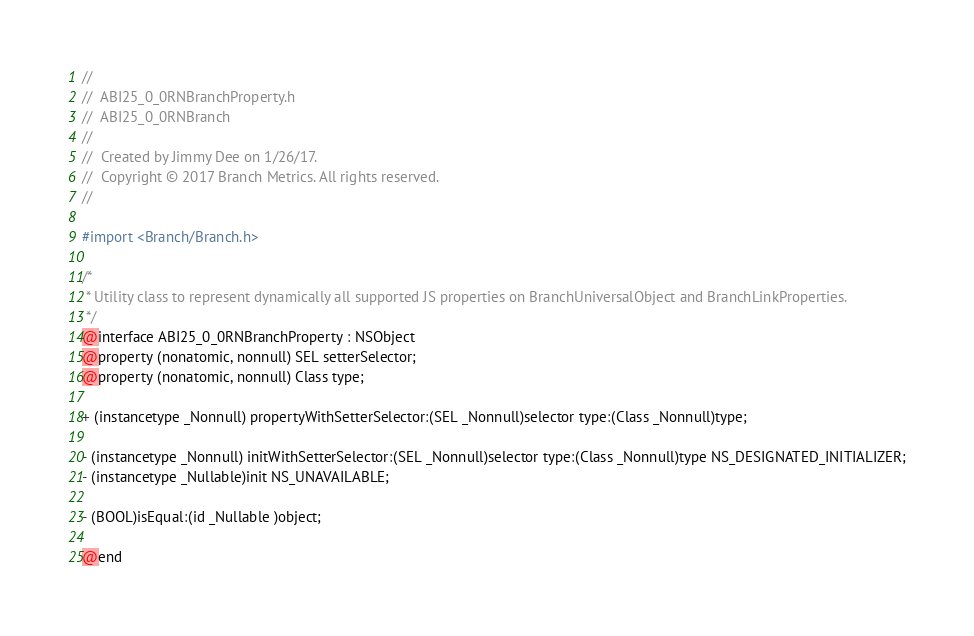<code> <loc_0><loc_0><loc_500><loc_500><_C_>//
//  ABI25_0_0RNBranchProperty.h
//  ABI25_0_0RNBranch
//
//  Created by Jimmy Dee on 1/26/17.
//  Copyright © 2017 Branch Metrics. All rights reserved.
//

#import <Branch/Branch.h>

/*
 * Utility class to represent dynamically all supported JS properties on BranchUniversalObject and BranchLinkProperties.
 */
@interface ABI25_0_0RNBranchProperty : NSObject
@property (nonatomic, nonnull) SEL setterSelector;
@property (nonatomic, nonnull) Class type;

+ (instancetype _Nonnull) propertyWithSetterSelector:(SEL _Nonnull)selector type:(Class _Nonnull)type;

- (instancetype _Nonnull) initWithSetterSelector:(SEL _Nonnull)selector type:(Class _Nonnull)type NS_DESIGNATED_INITIALIZER;
- (instancetype _Nullable)init NS_UNAVAILABLE;

- (BOOL)isEqual:(id _Nullable )object;

@end
</code> 